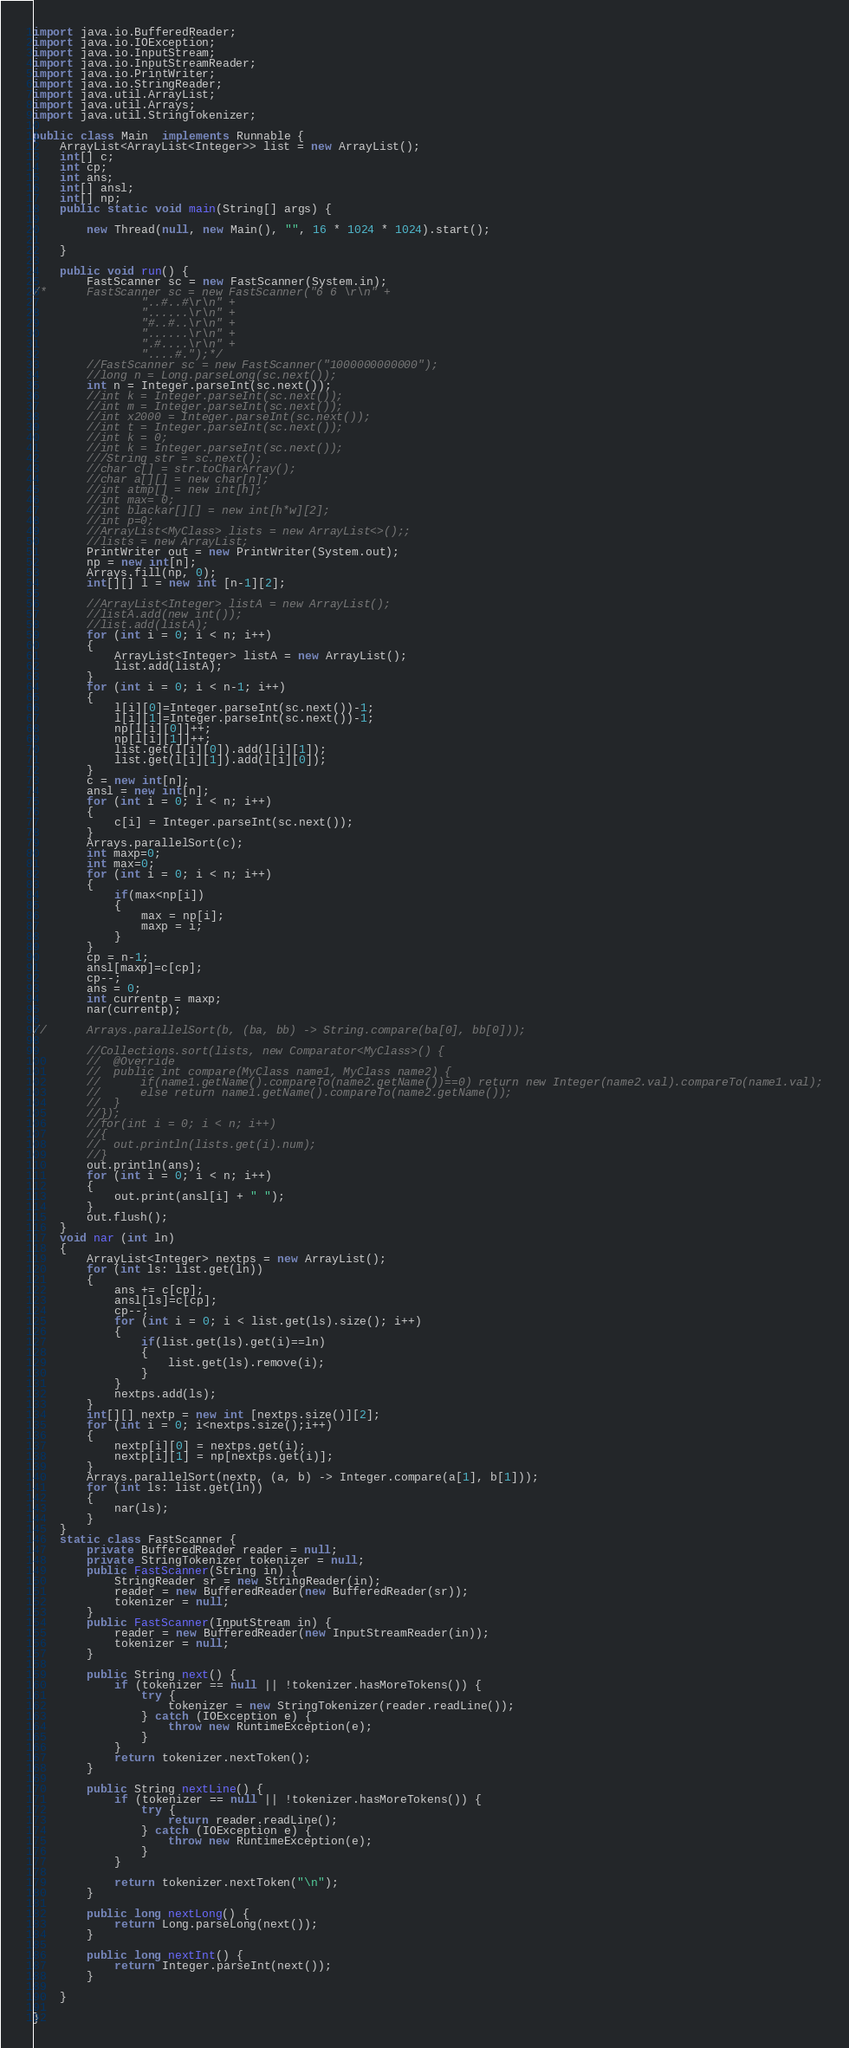Convert code to text. <code><loc_0><loc_0><loc_500><loc_500><_Java_>import java.io.BufferedReader;
import java.io.IOException;
import java.io.InputStream;
import java.io.InputStreamReader;
import java.io.PrintWriter;
import java.io.StringReader;
import java.util.ArrayList;
import java.util.Arrays;
import java.util.StringTokenizer;

public class Main  implements Runnable {
	ArrayList<ArrayList<Integer>> list = new ArrayList();
	int[] c;
	int cp;
	int ans;
	int[] ansl;
	int[] np;
    public static void main(String[] args) {

        new Thread(null, new Main(), "", 16 * 1024 * 1024).start();

    }

    public void run() {
    	FastScanner sc = new FastScanner(System.in);
/*		FastScanner sc = new FastScanner("6 6 \r\n" +
				"..#..#\r\n" +
				"......\r\n" +
				"#..#..\r\n" +
				"......\r\n" +
				".#....\r\n" +
				"....#.");*/
    	//FastScanner sc = new FastScanner("1000000000000");
		//long n = Long.parseLong(sc.next());
		int n = Integer.parseInt(sc.next());
		//int k = Integer.parseInt(sc.next());
		//int m = Integer.parseInt(sc.next());
		//int x2000 = Integer.parseInt(sc.next());
		//int t = Integer.parseInt(sc.next());
		//int k = 0;
		//int k = Integer.parseInt(sc.next());
		///String str = sc.next();
		//char c[] = str.toCharArray();
		//char a[][] = new char[n];
		//int atmp[] = new int[h];
		//int max= 0;
		//int blackar[][] = new int[h*w][2];
		//int p=0;
		//ArrayList<MyClass> lists = new ArrayList<>();;
		//lists = new ArrayList;
		PrintWriter out = new PrintWriter(System.out);
		np = new int[n];
		Arrays.fill(np, 0);
		int[][] l = new int [n-1][2];

		//ArrayList<Integer> listA = new ArrayList();
		//listA.add(new int());
		//list.add(listA);
		for (int i = 0; i < n; i++)
		{
			ArrayList<Integer> listA = new ArrayList();
			list.add(listA);
		}
		for (int i = 0; i < n-1; i++)
		{
			l[i][0]=Integer.parseInt(sc.next())-1;
			l[i][1]=Integer.parseInt(sc.next())-1;
			np[l[i][0]]++;
			np[l[i][1]]++;
			list.get(l[i][0]).add(l[i][1]);
			list.get(l[i][1]).add(l[i][0]);
		}
		c = new int[n];
		ansl = new int[n];
		for (int i = 0; i < n; i++)
		{
			c[i] = Integer.parseInt(sc.next());
		}
		Arrays.parallelSort(c);
		int maxp=0;
		int max=0;
		for (int i = 0; i < n; i++)
		{
			if(max<np[i])
			{
				max = np[i];
				maxp = i;
			}
		}
		cp = n-1;
		ansl[maxp]=c[cp];
		cp--;
		ans = 0;
		int currentp = maxp;
		nar(currentp);

//		Arrays.parallelSort(b, (ba, bb) -> String.compare(ba[0], bb[0]));

		//Collections.sort(lists, new Comparator<MyClass>() {
		//	@Override
		//	public int compare(MyClass name1, MyClass name2) {
		//		if(name1.getName().compareTo(name2.getName())==0) return new Integer(name2.val).compareTo(name1.val);
		//		else return name1.getName().compareTo(name2.getName());
		//	}
		//});
		//for(int i = 0; i < n; i++)
		//{
		//	out.println(lists.get(i).num);
		//}
		out.println(ans);
		for (int i = 0; i < n; i++)
		{
			out.print(ansl[i] + " ");
		}
		out.flush();
	}
    void nar (int ln)
    {
		ArrayList<Integer> nextps = new ArrayList();
		for (int ls: list.get(ln))
		{
			ans += c[cp];
			ansl[ls]=c[cp];
			cp--;
			for (int i = 0; i < list.get(ls).size(); i++)
			{
				if(list.get(ls).get(i)==ln)
				{
					list.get(ls).remove(i);
				}
			}
			nextps.add(ls);
		}
		int[][] nextp = new int [nextps.size()][2];
		for (int i = 0; i<nextps.size();i++)
		{
			nextp[i][0] = nextps.get(i);
			nextp[i][1] = np[nextps.get(i)];
		}
		Arrays.parallelSort(nextp, (a, b) -> Integer.compare(a[1], b[1]));
		for (int ls: list.get(ln))
		{
			nar(ls);
		}
    }
    static class FastScanner {
        private BufferedReader reader = null;
        private StringTokenizer tokenizer = null;
        public FastScanner(String in) {
        	StringReader sr = new StringReader(in);
            reader = new BufferedReader(new BufferedReader(sr));
            tokenizer = null;
        }
        public FastScanner(InputStream in) {
            reader = new BufferedReader(new InputStreamReader(in));
            tokenizer = null;
        }

        public String next() {
            if (tokenizer == null || !tokenizer.hasMoreTokens()) {
                try {
                    tokenizer = new StringTokenizer(reader.readLine());
                } catch (IOException e) {
                    throw new RuntimeException(e);
                }
            }
            return tokenizer.nextToken();
        }

        public String nextLine() {
            if (tokenizer == null || !tokenizer.hasMoreTokens()) {
                try {
                    return reader.readLine();
                } catch (IOException e) {
                    throw new RuntimeException(e);
                }
            }

            return tokenizer.nextToken("\n");
        }

        public long nextLong() {
            return Long.parseLong(next());
        }

        public long nextInt() {
            return Integer.parseInt(next());
        }

    }

}</code> 